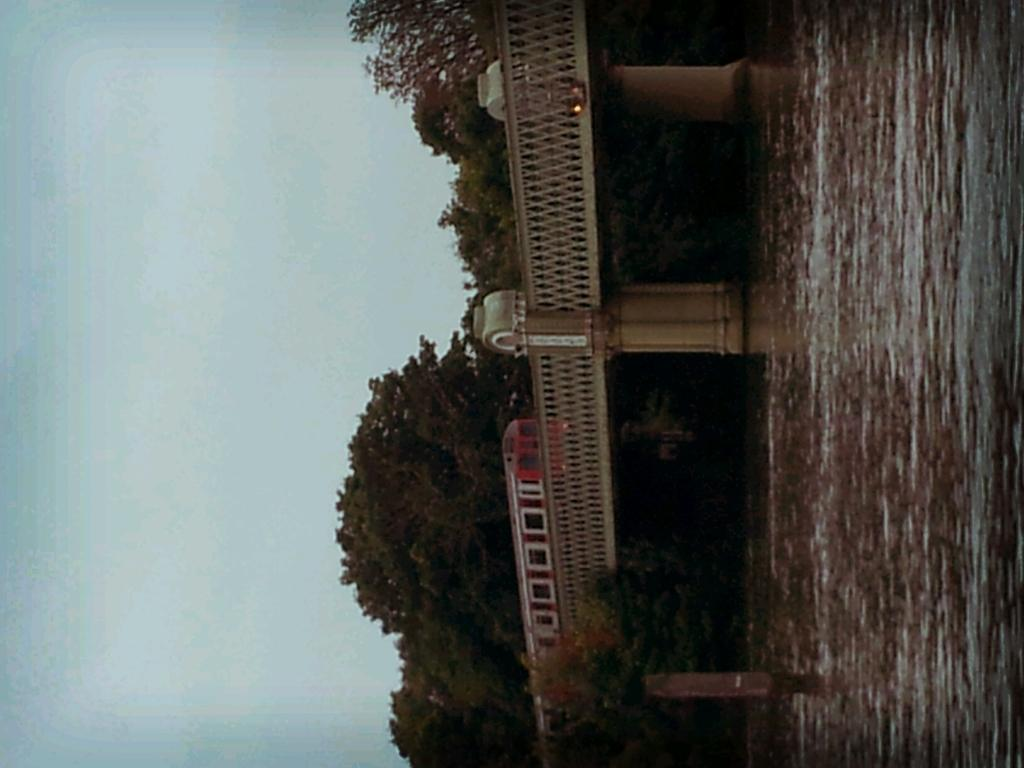What is on the bridge in the image? There is a vehicle on the bridge in the image. What can be seen below the bridge? Water is visible in the image. What type of vegetation is present in the image? There are trees in the image. What is visible in the background of the image? The sky is visible in the background of the image. What type of flower can be seen growing on the bridge in the image? There are no flowers visible on the bridge in the image. Is there any popcorn present in the image? There is no popcorn present in the image. 